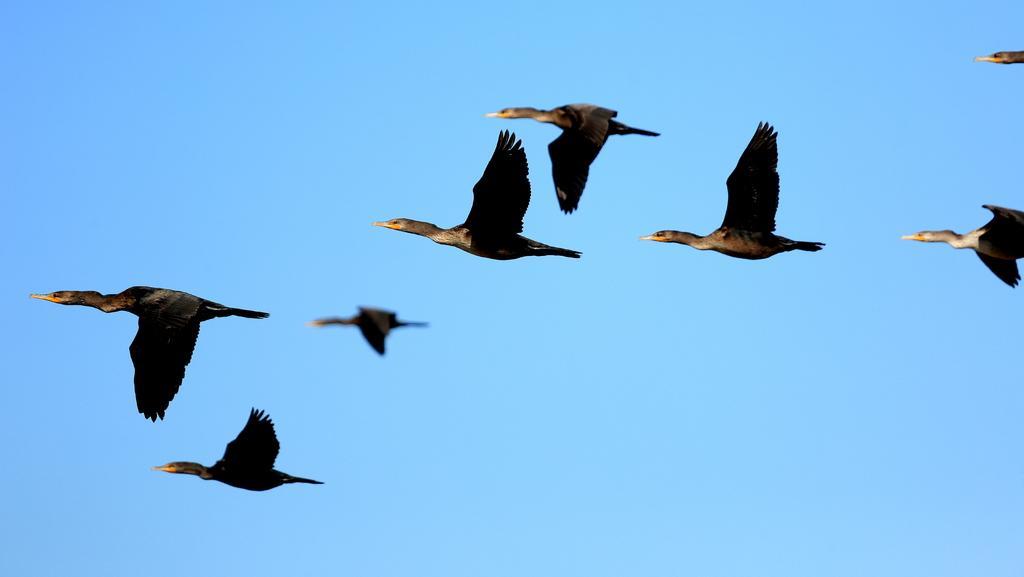Please provide a concise description of this image. In this image we can see some birds which are of black and brown color flying in the sky and at the background of the image there is clear sky. 